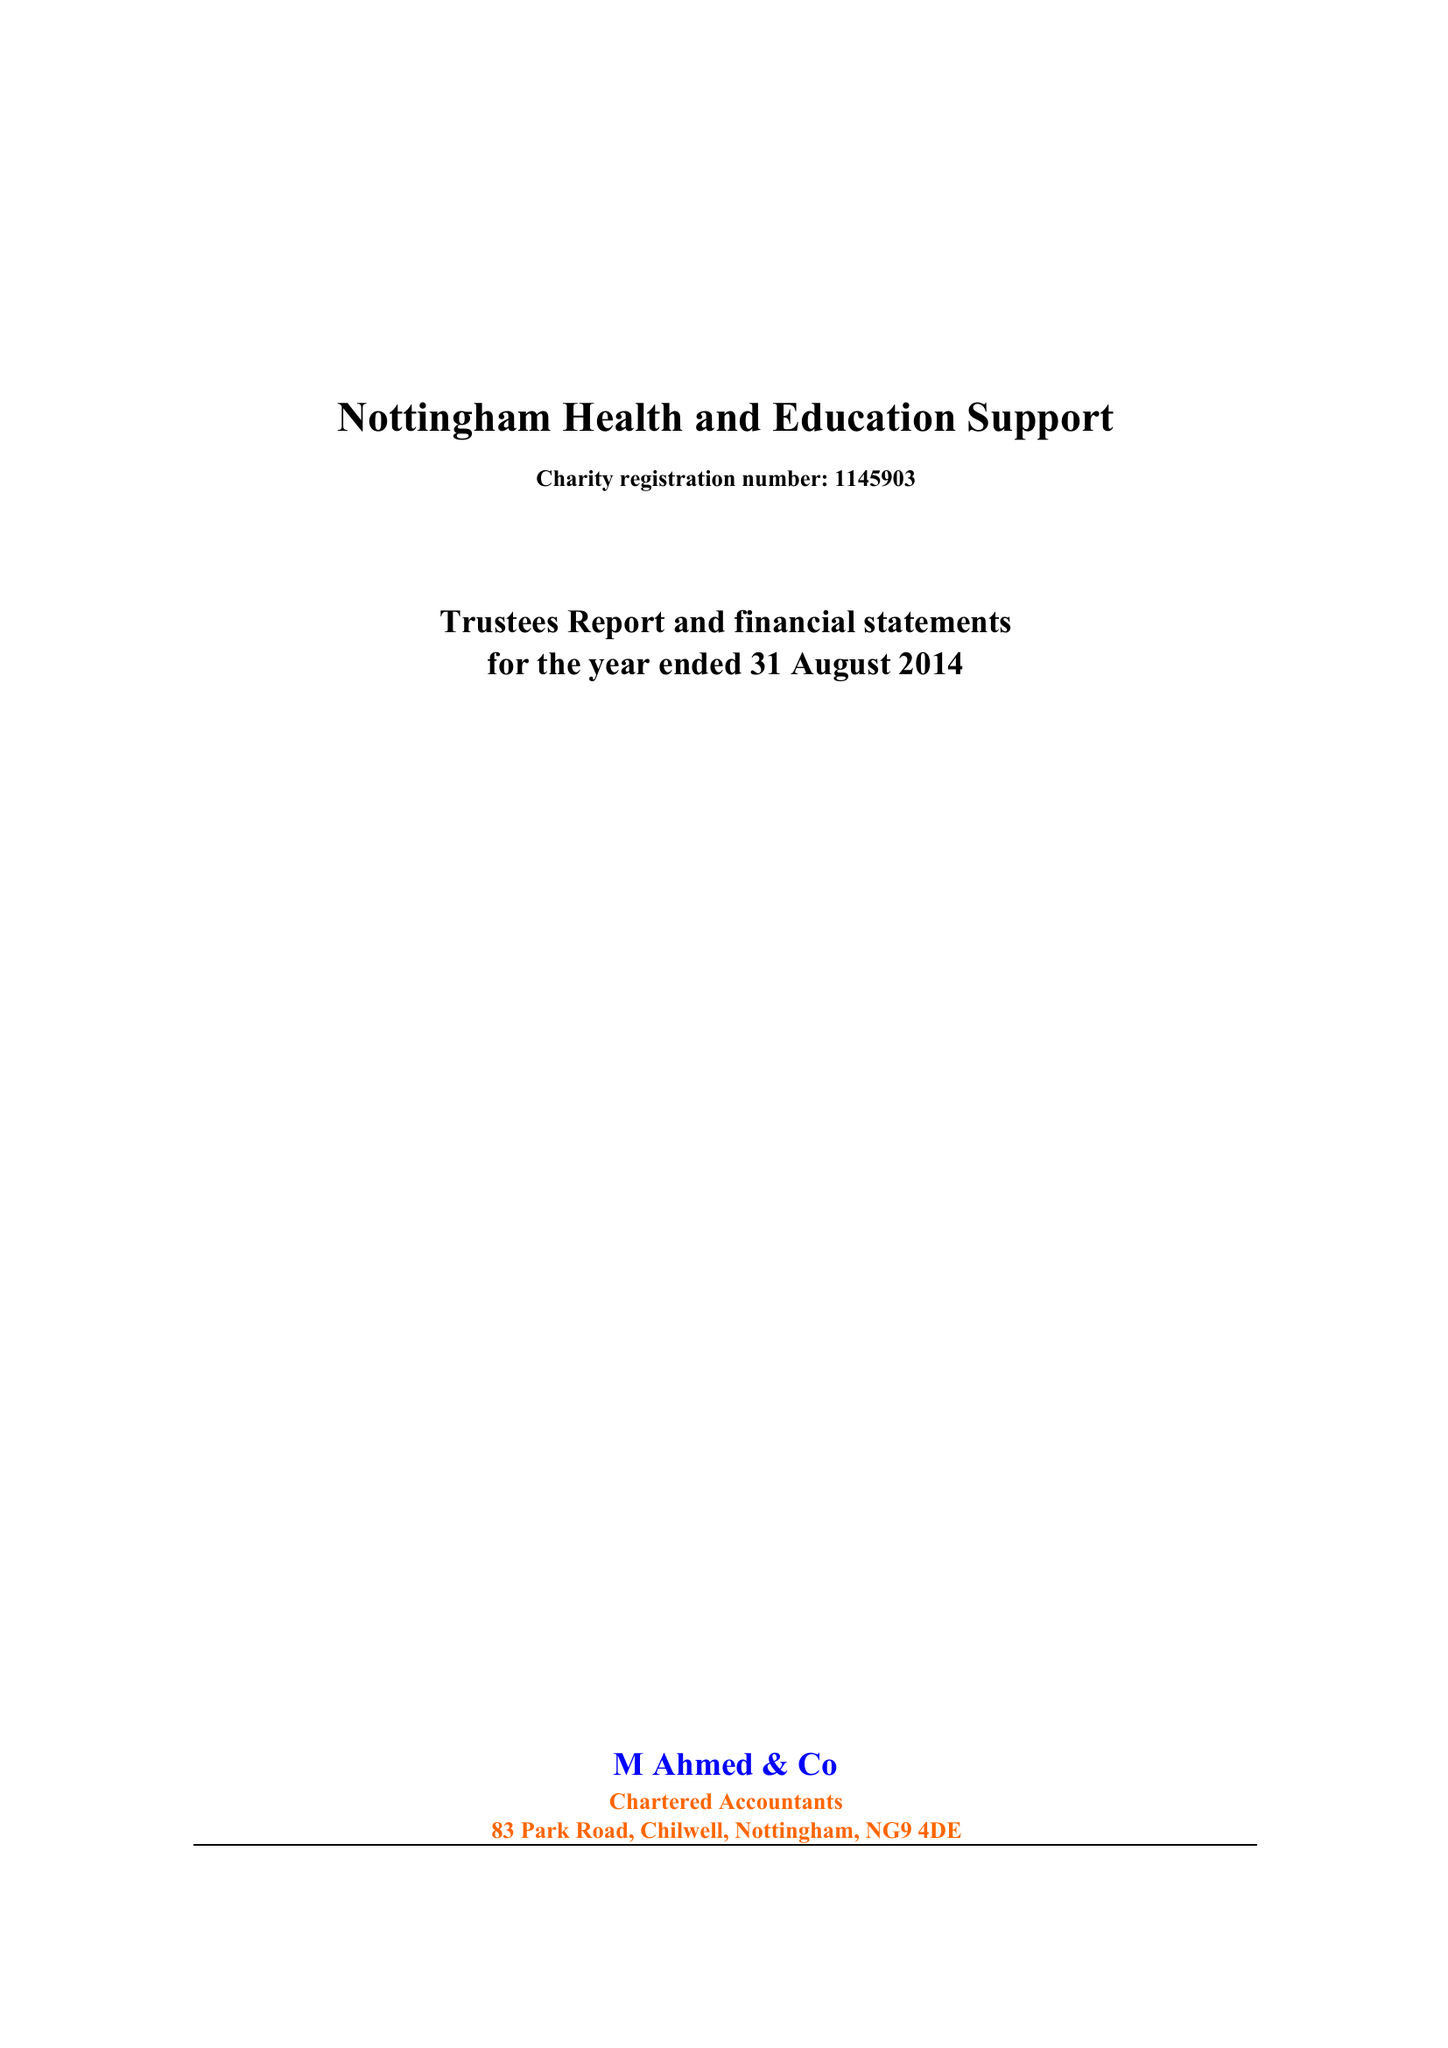What is the value for the address__post_town?
Answer the question using a single word or phrase. NOTTINGHAM 